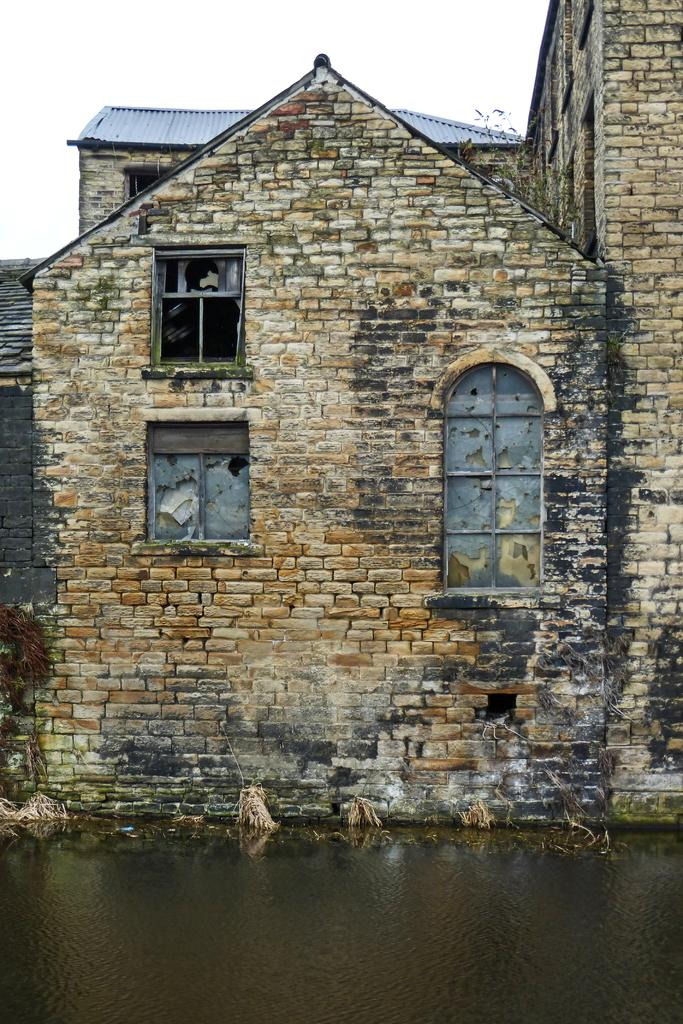What is one of the natural elements visible in the image? The sky is visible in the image. What can be seen in the sky in the image? Clouds are present in the image. What type of surface can be seen in the image? There is water visible in the image. What architectural features are present in the image? Windows and a roof are visible in the image. What type of material is used for a part of the structure in the image? A brick wall is visible in the image. What type of food is being cooked in the image? There is no indication of food or cooking in the image. How many mines can be seen in the image? There are no mines present in the image. 